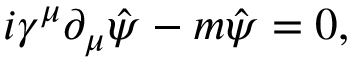<formula> <loc_0><loc_0><loc_500><loc_500>i \gamma ^ { \mu } \partial _ { \mu } \hat { \psi } - m { \hat { \psi } } = 0 ,</formula> 